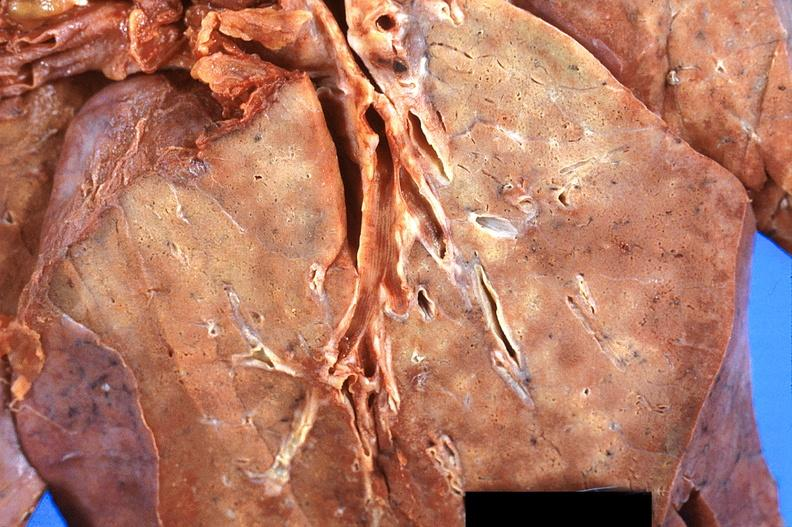does this image show lung, diffuse alveolar damage?
Answer the question using a single word or phrase. Yes 